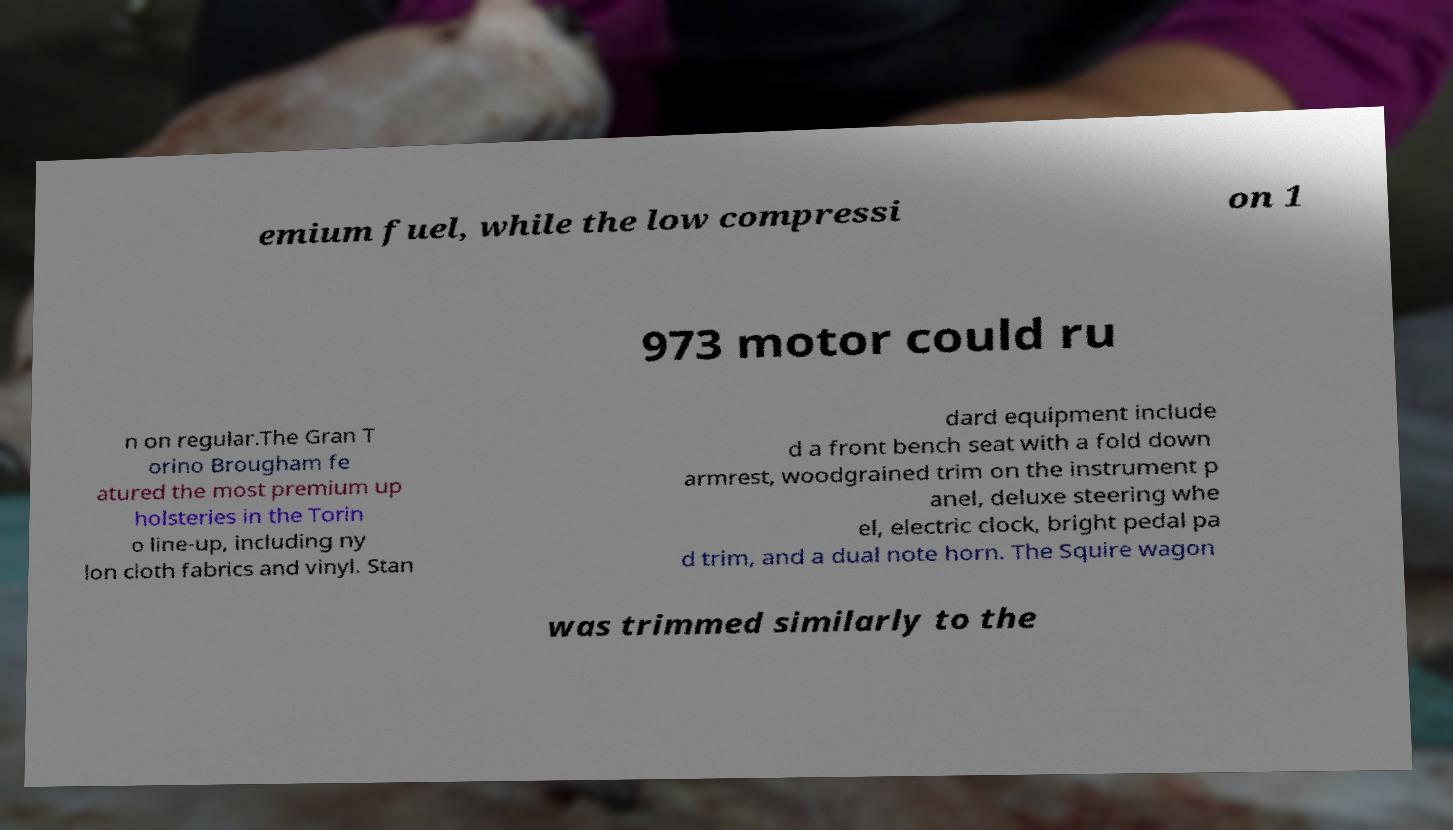What messages or text are displayed in this image? I need them in a readable, typed format. emium fuel, while the low compressi on 1 973 motor could ru n on regular.The Gran T orino Brougham fe atured the most premium up holsteries in the Torin o line-up, including ny lon cloth fabrics and vinyl. Stan dard equipment include d a front bench seat with a fold down armrest, woodgrained trim on the instrument p anel, deluxe steering whe el, electric clock, bright pedal pa d trim, and a dual note horn. The Squire wagon was trimmed similarly to the 